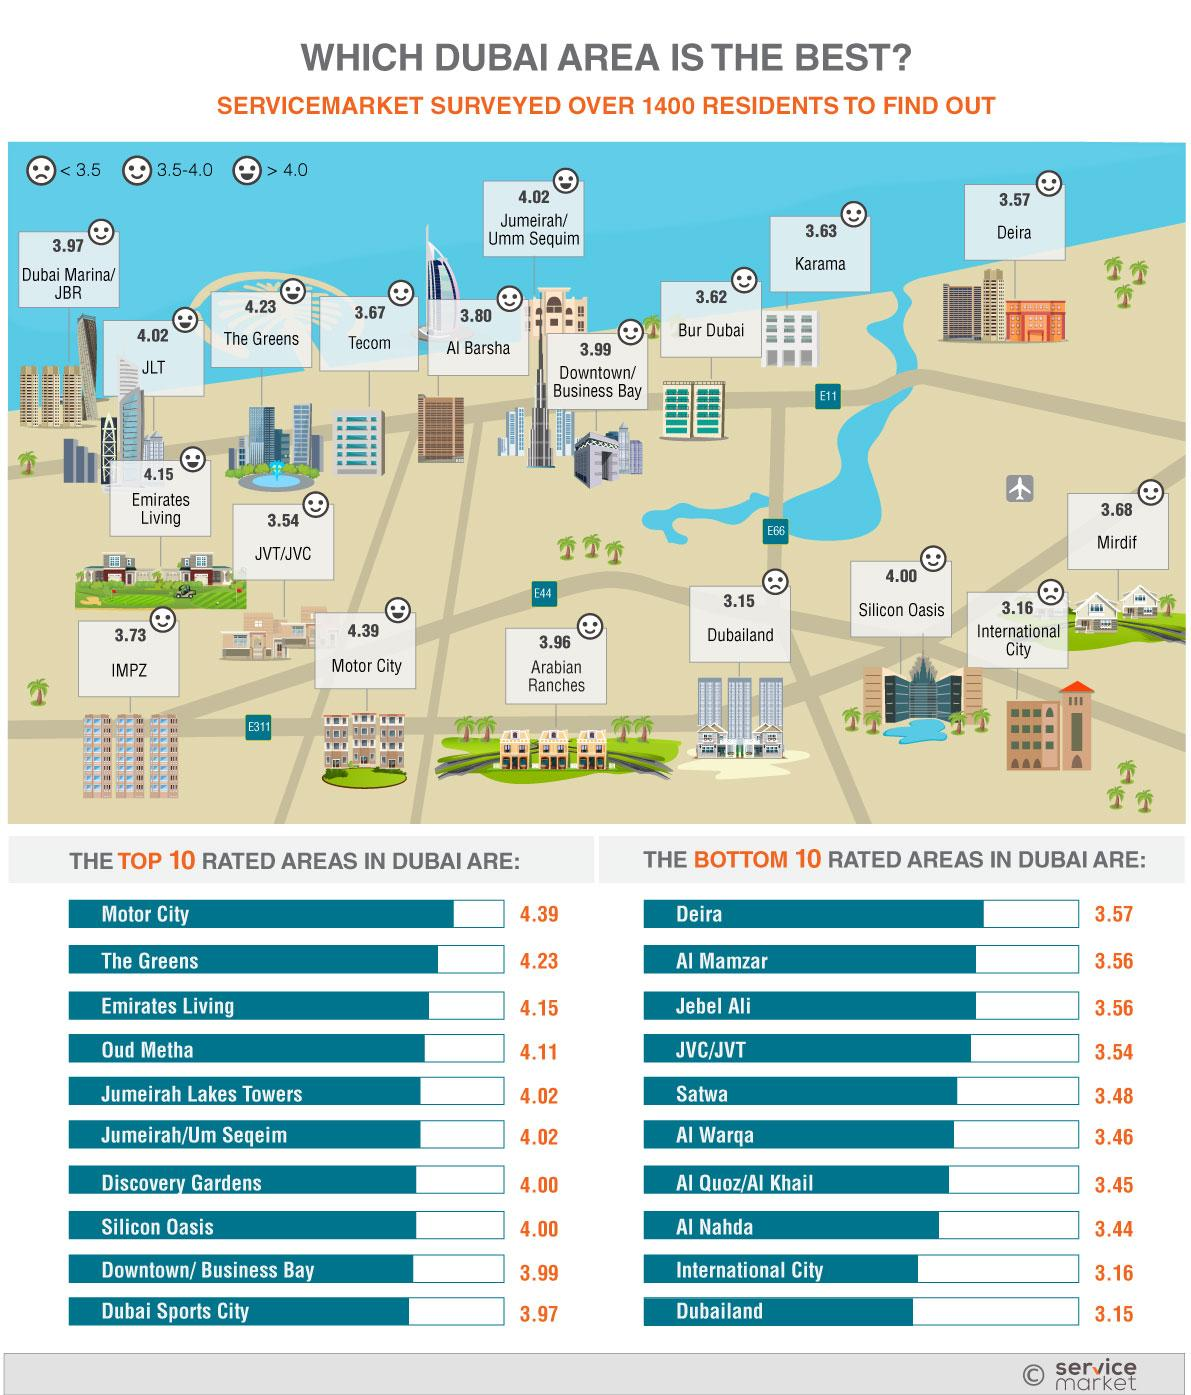Give some essential details in this illustration. According to a service market survey of over 1400 residents, Dubailand is the least rated area in Dubai. The Greens is the second most highly rated area in Dubai according to a service market survey of over 1400 residents. According to the service market survey of over 1400 residents, Dubai Sports City has received a rating of 3.97 out of 5 for its exceptional service. According to a recent service market survey of over 1400 residents in Dubai, International City is the second least rated area in terms of service quality. According to a recent service market survey conducted among over 1400 residents in Dubai, Emirates Living has been rated as 4.15 out of 5 in terms of its exceptional service offerings. 